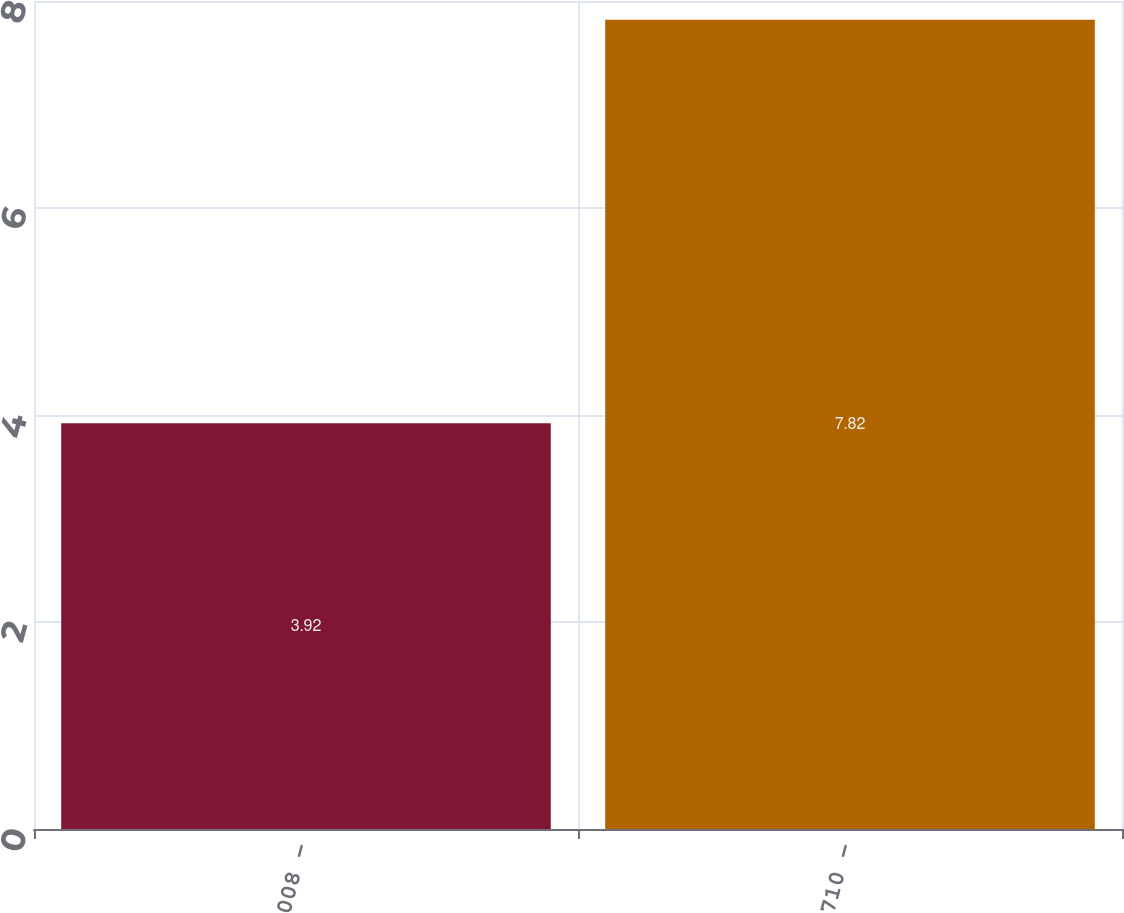Convert chart to OTSL. <chart><loc_0><loc_0><loc_500><loc_500><bar_chart><fcel>008 -<fcel>710 -<nl><fcel>3.92<fcel>7.82<nl></chart> 